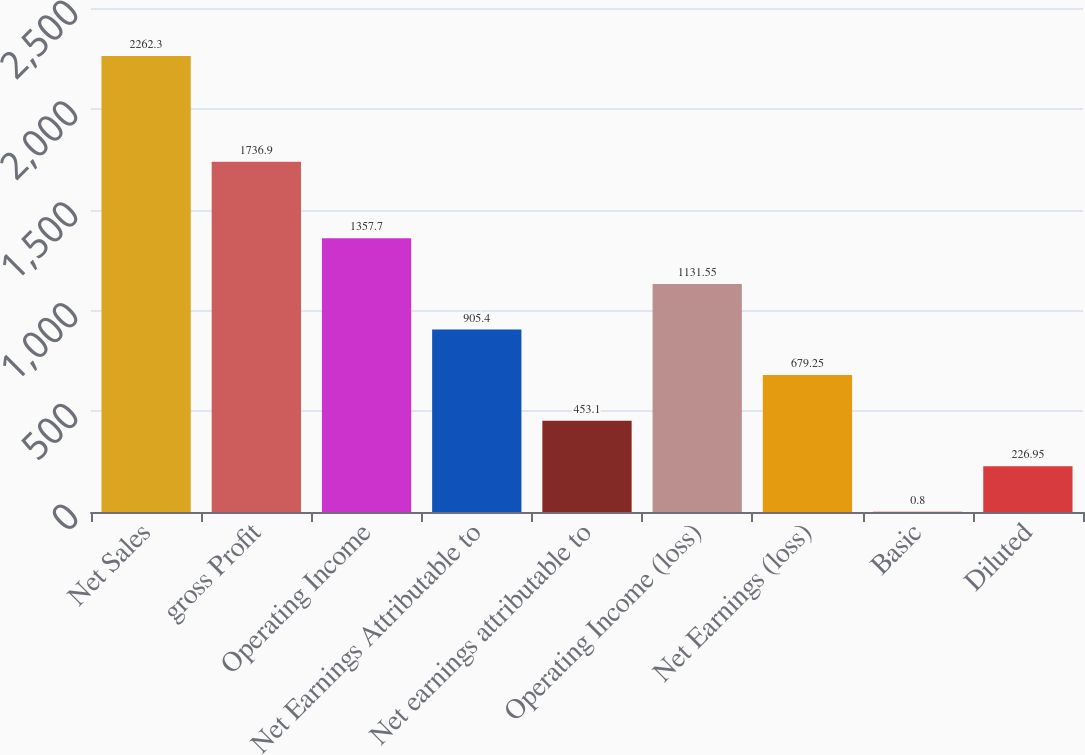<chart> <loc_0><loc_0><loc_500><loc_500><bar_chart><fcel>Net Sales<fcel>gross Profit<fcel>Operating Income<fcel>Net Earnings Attributable to<fcel>Net earnings attributable to<fcel>Operating Income (loss)<fcel>Net Earnings (loss)<fcel>Basic<fcel>Diluted<nl><fcel>2262.3<fcel>1736.9<fcel>1357.7<fcel>905.4<fcel>453.1<fcel>1131.55<fcel>679.25<fcel>0.8<fcel>226.95<nl></chart> 